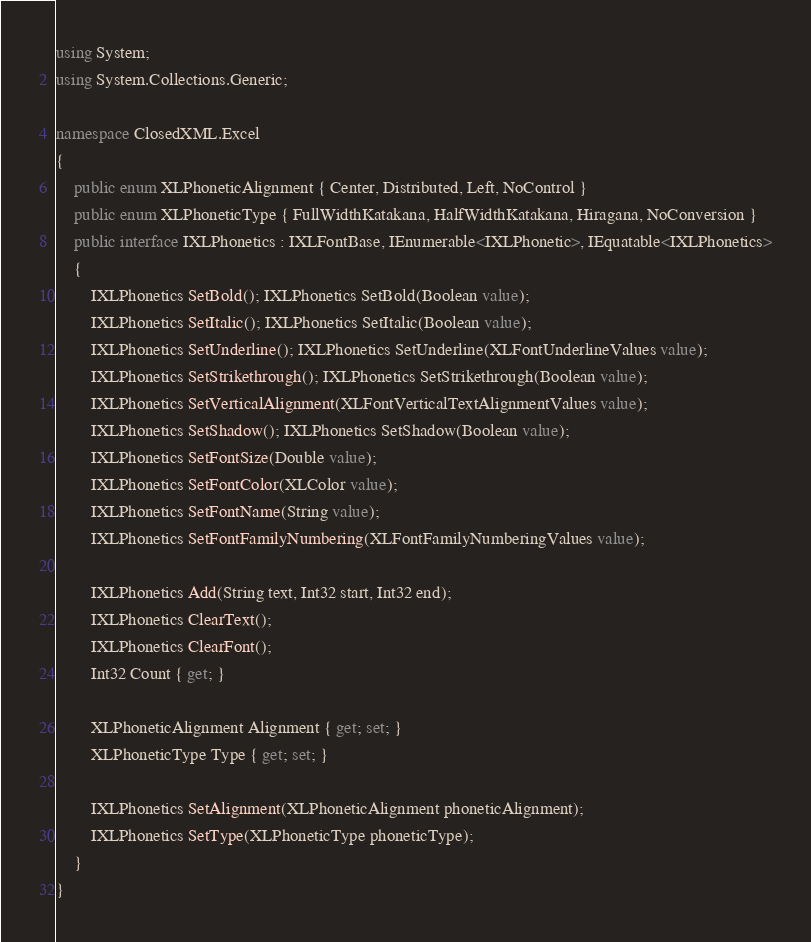<code> <loc_0><loc_0><loc_500><loc_500><_C#_>using System;
using System.Collections.Generic;

namespace ClosedXML.Excel
{
    public enum XLPhoneticAlignment { Center, Distributed, Left, NoControl }
    public enum XLPhoneticType { FullWidthKatakana, HalfWidthKatakana, Hiragana, NoConversion }
    public interface IXLPhonetics : IXLFontBase, IEnumerable<IXLPhonetic>, IEquatable<IXLPhonetics>
    {
        IXLPhonetics SetBold(); IXLPhonetics SetBold(Boolean value);
        IXLPhonetics SetItalic(); IXLPhonetics SetItalic(Boolean value);
        IXLPhonetics SetUnderline(); IXLPhonetics SetUnderline(XLFontUnderlineValues value);
        IXLPhonetics SetStrikethrough(); IXLPhonetics SetStrikethrough(Boolean value);
        IXLPhonetics SetVerticalAlignment(XLFontVerticalTextAlignmentValues value);
        IXLPhonetics SetShadow(); IXLPhonetics SetShadow(Boolean value);
        IXLPhonetics SetFontSize(Double value);
        IXLPhonetics SetFontColor(XLColor value);
        IXLPhonetics SetFontName(String value);
        IXLPhonetics SetFontFamilyNumbering(XLFontFamilyNumberingValues value);

        IXLPhonetics Add(String text, Int32 start, Int32 end);
        IXLPhonetics ClearText();
        IXLPhonetics ClearFont();
        Int32 Count { get; }

        XLPhoneticAlignment Alignment { get; set; }
        XLPhoneticType Type { get; set; }

        IXLPhonetics SetAlignment(XLPhoneticAlignment phoneticAlignment);
        IXLPhonetics SetType(XLPhoneticType phoneticType);
    }
}
</code> 